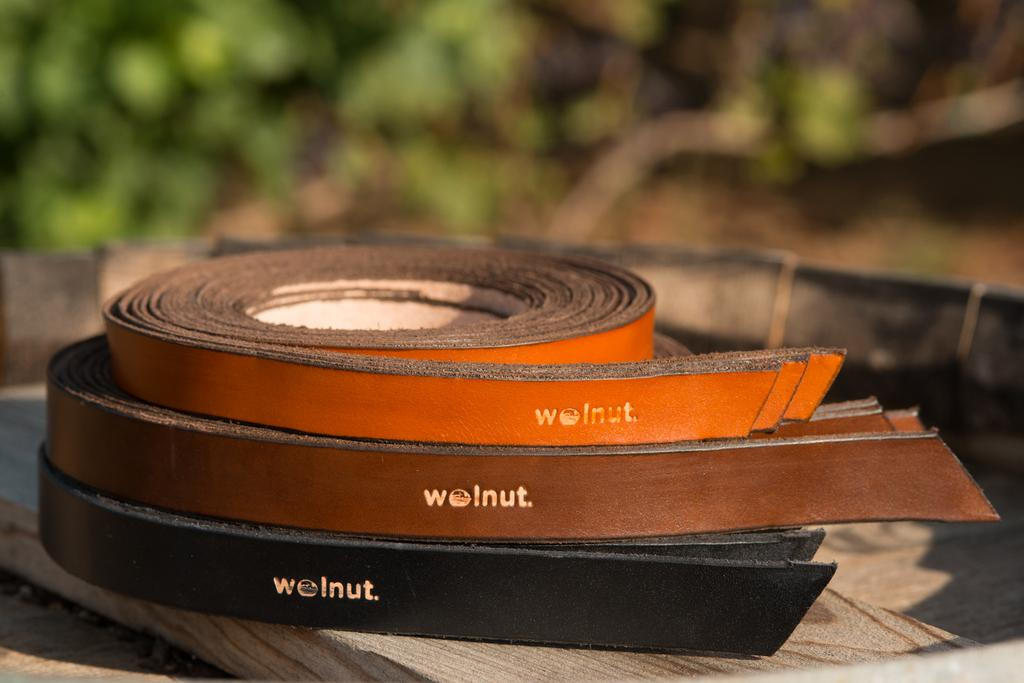What is placed on the wooden plank in the image? There are bets placed on a wooden plank in the image. What can be seen in the distance in the image? There are trees visible in the background of the image. How would you describe the appearance of the background? The background appears blurry. What type of twig is being used to balance the bets on the wooden plank? There is no twig present in the image, and the bets are not being balanced on the wooden plank. Who is the owner of the bets in the image? There is no information about the ownership of the bets in the image. 